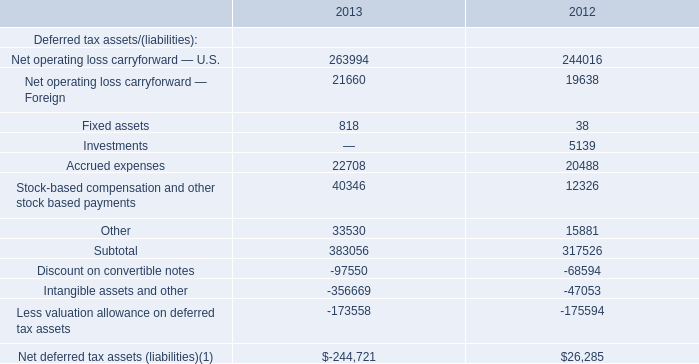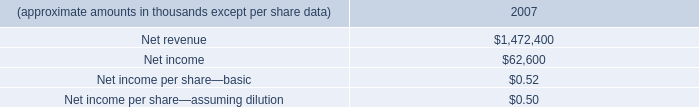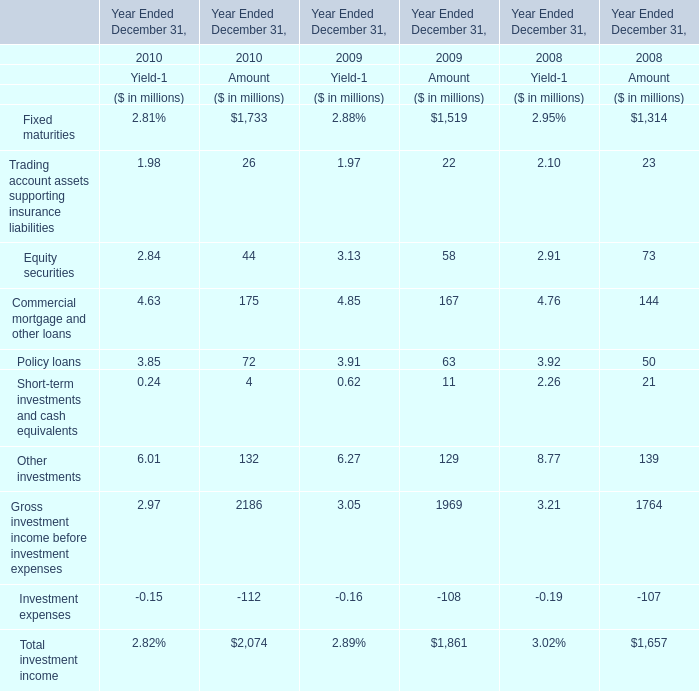In which year Ended December 31 is the Amount of Equity securities smaller than 50 million? 
Answer: 2010. 